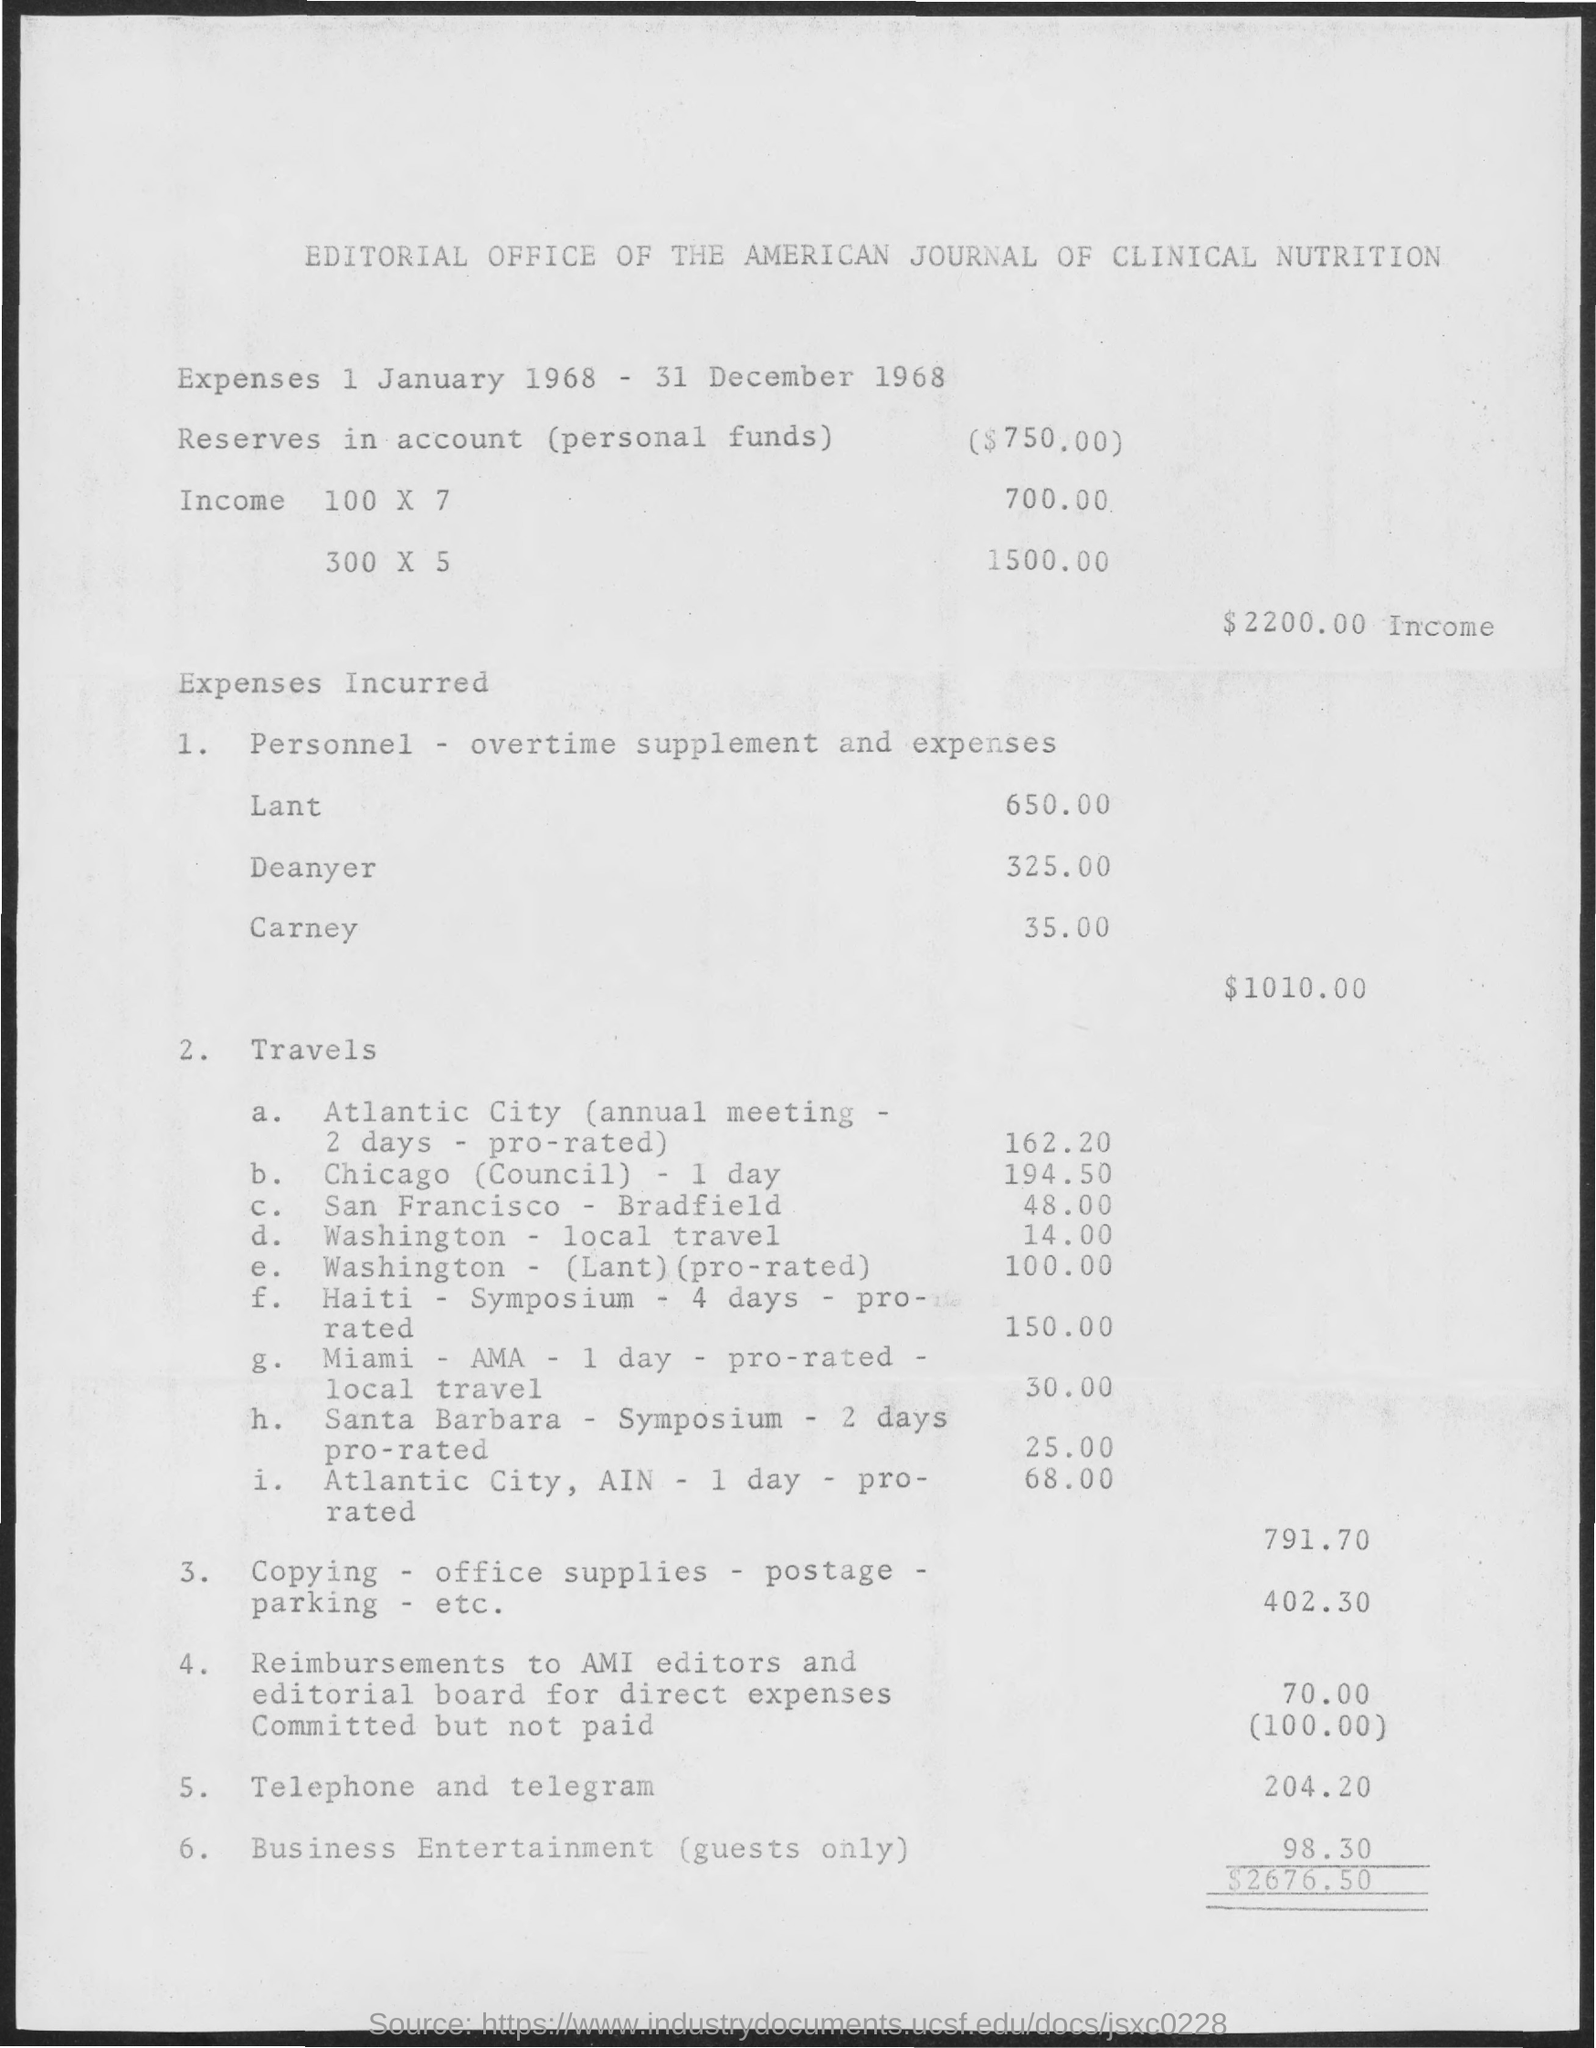What duration is the expenses for?
Offer a very short reply. 1 January 1968 - 31 December 1968. What are the total expenses incurred in personnel?
Your answer should be very brief. 1010.00. 